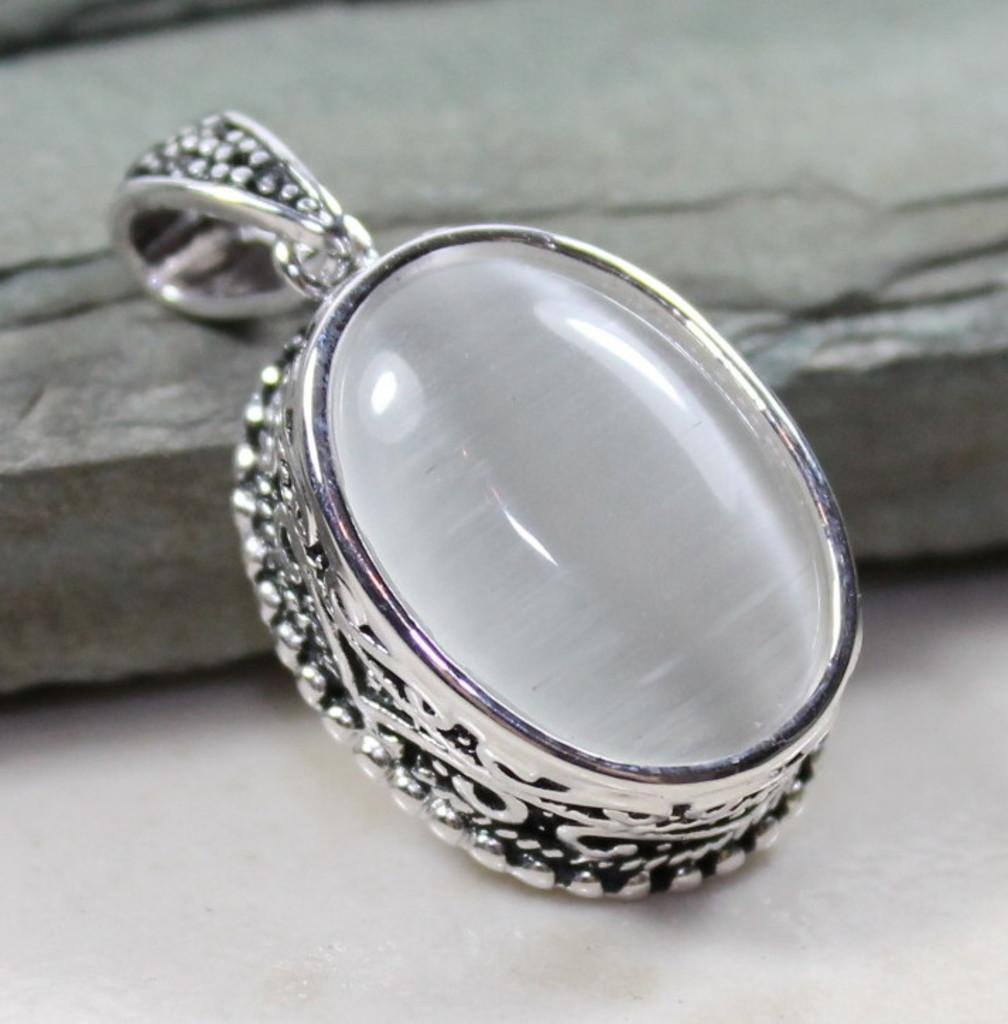What is the main subject of the image? The main subject of the image is a pendant. Can you describe the pendant in the image? Unfortunately, the provided facts do not give any details about the pendant's appearance or design. What else can be seen in the image besides the pendant? There is a stone in the background of the image. What hobbies does the person holding the bag in the image enjoy? There is no person holding a bag in the image, nor is there any information about hobbies. 